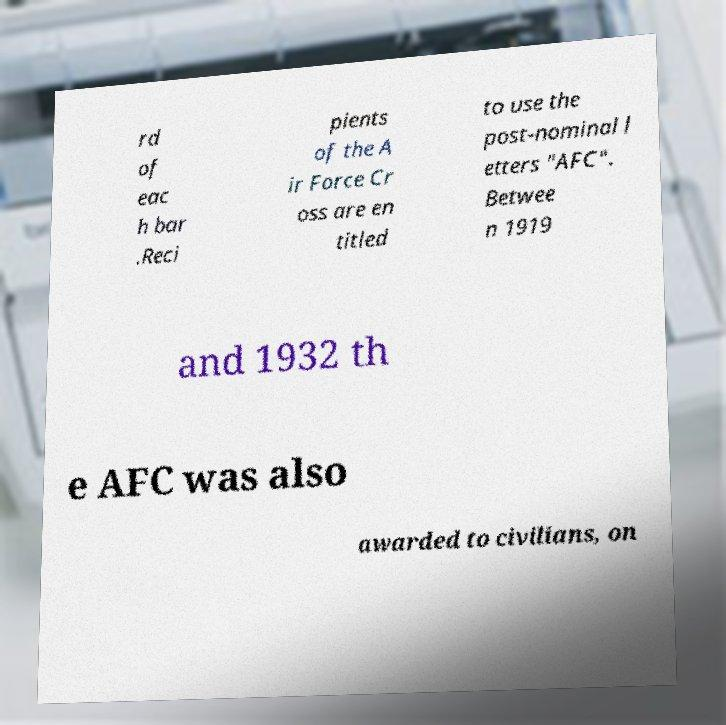Please identify and transcribe the text found in this image. rd of eac h bar .Reci pients of the A ir Force Cr oss are en titled to use the post-nominal l etters "AFC". Betwee n 1919 and 1932 th e AFC was also awarded to civilians, on 